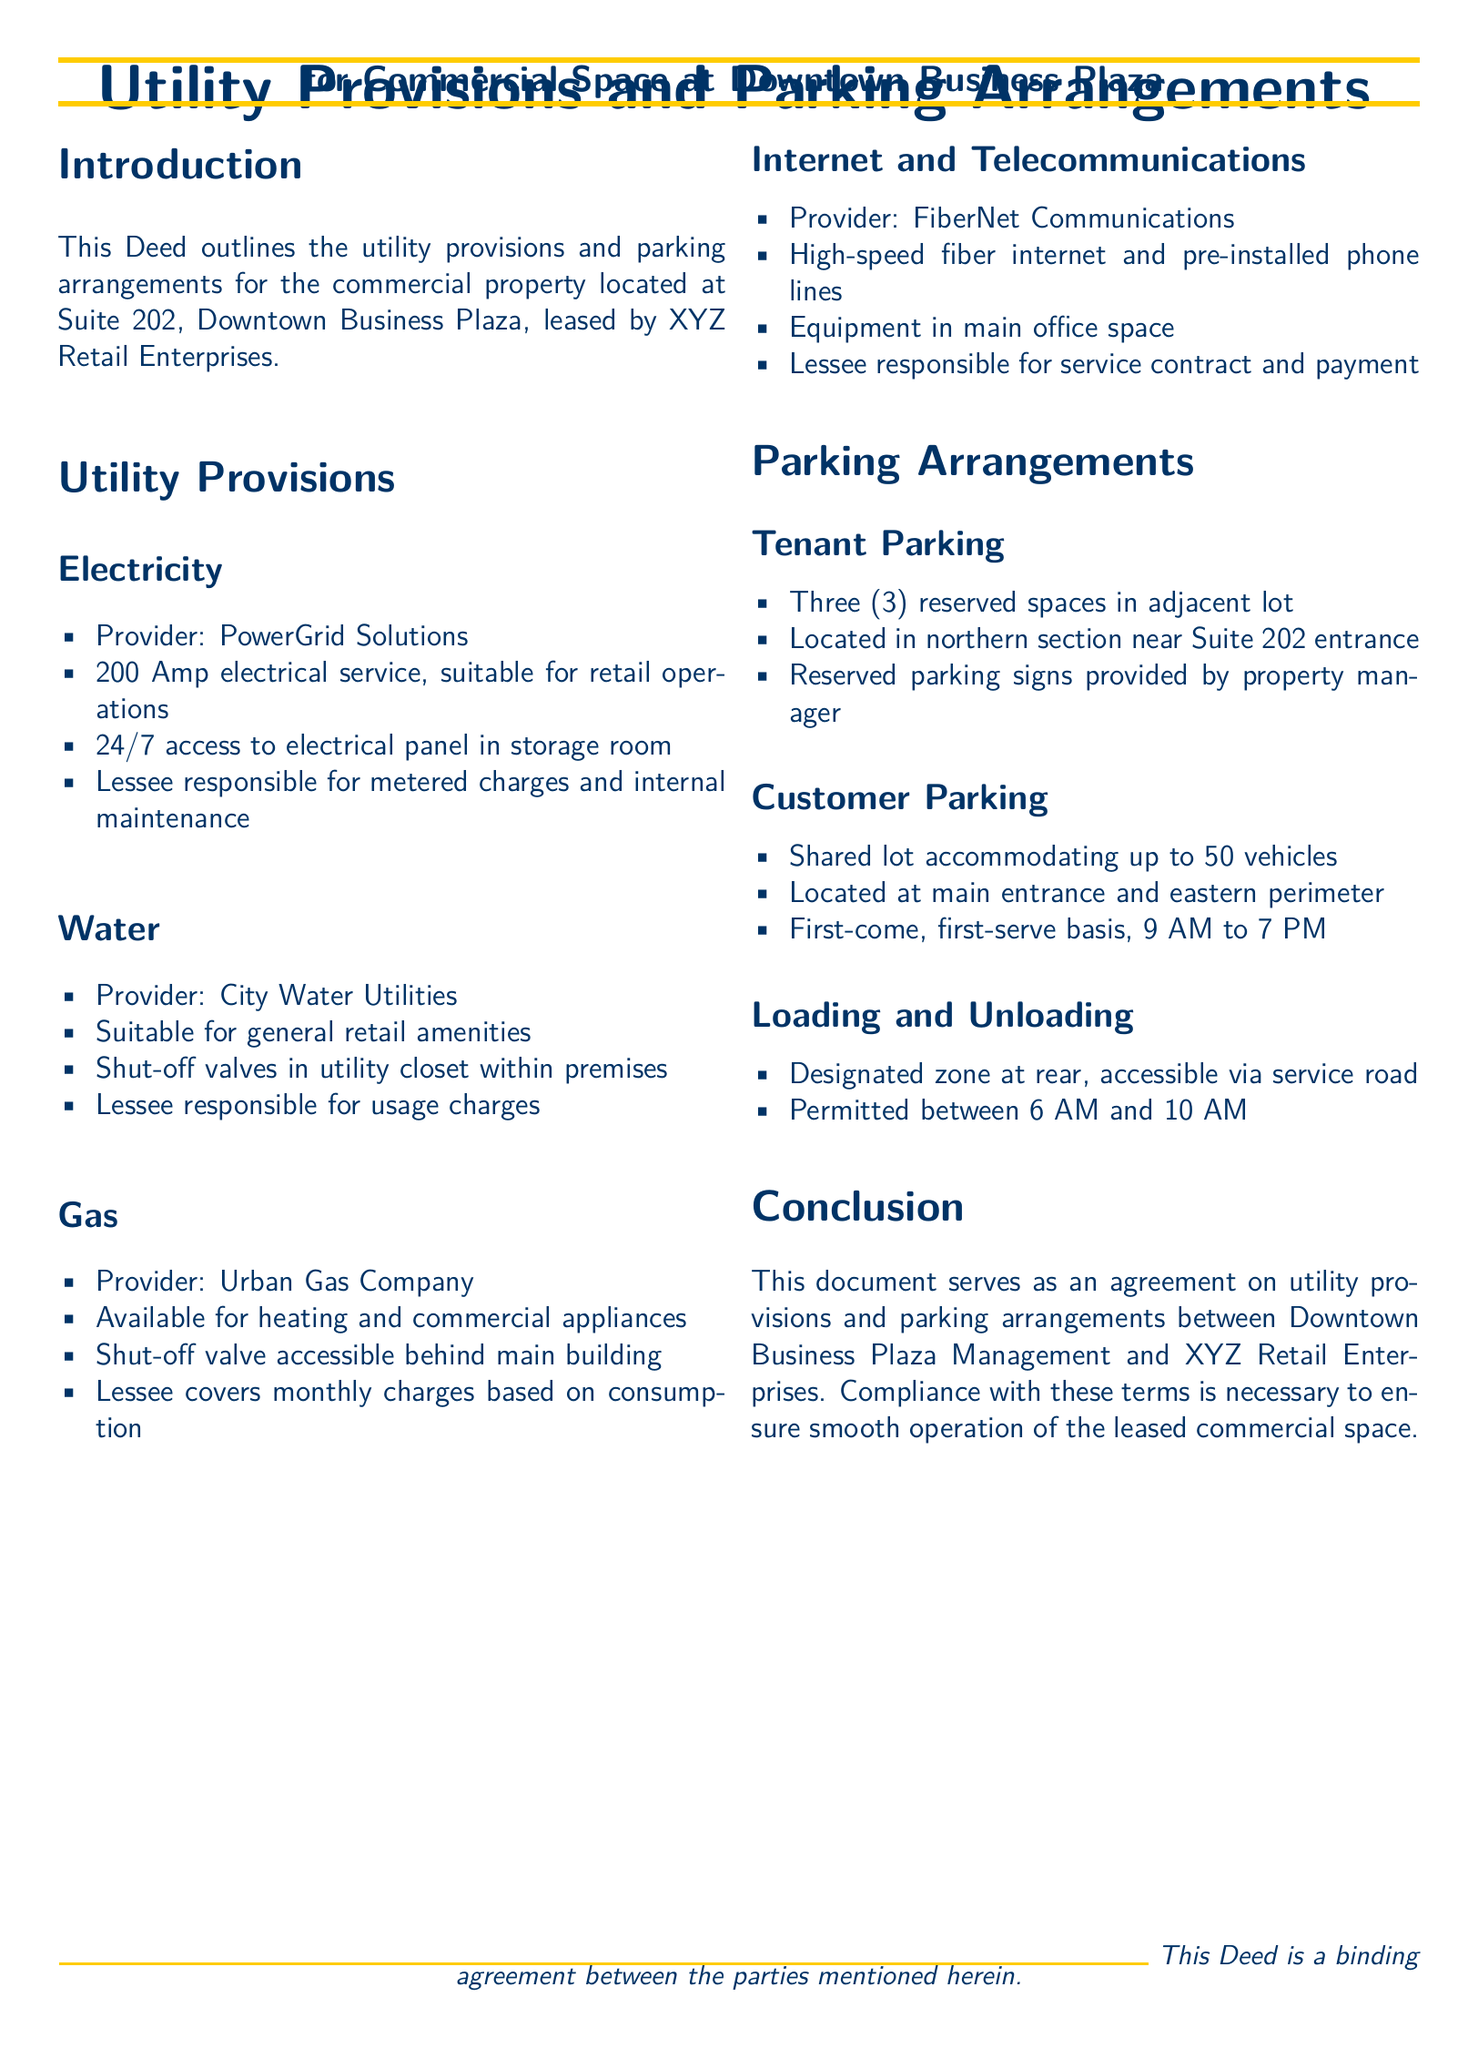What is the provider for electricity? The document specifies that the electricity provider is PowerGrid Solutions.
Answer: PowerGrid Solutions How many reserved parking spaces are available for tenants? The document states that there are three reserved spaces in the adjacent lot for tenants.
Answer: Three What is the maximum number of vehicles allowed in the customer parking lot? The customer parking lot can accommodate up to 50 vehicles, as mentioned in the document.
Answer: 50 What is the address of the leased commercial space? The address of the leased commercial space is Suite 202, Downtown Business Plaza.
Answer: Suite 202, Downtown Business Plaza What is the permitted time for loading and unloading? Loading and unloading are permitted between 6 AM and 10 AM, according to the document.
Answer: 6 AM to 10 AM What utility is provided by Urban Gas Company? The gas provider is Urban Gas Company, and it is available for heating and commercial appliances.
Answer: Gas Who is responsible for the metered charges for electricity? The lessee is responsible for the metered charges and internal maintenance regarding electricity.
Answer: Lessee What is the access schedule for customer parking? Customer parking is available on a first-come, first-serve basis from 9 AM to 7 PM.
Answer: 9 AM to 7 PM What document type is this? The document is a deed that outlines utility provisions and parking arrangements.
Answer: Deed 